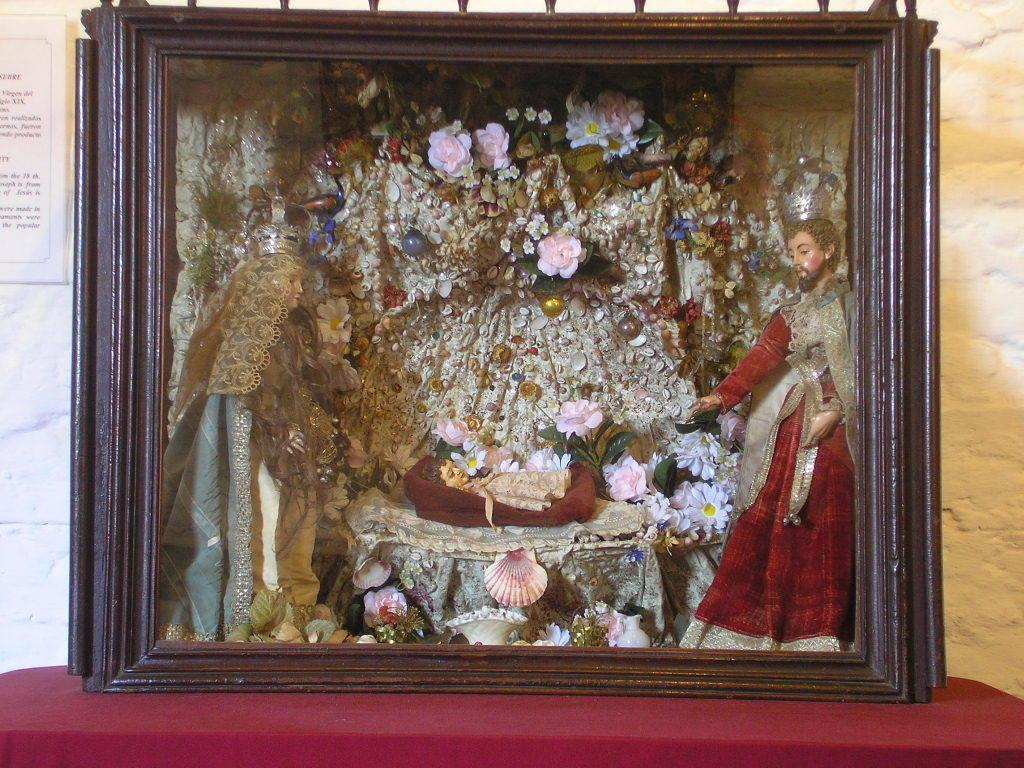What is the main object on the platform in the image? There is a photo frame on a platform in the image. What is depicted inside the photo frame? The photo frame contains a statue of people and flowers. Are there any other objects in the photo frame besides the statue and flowers? Yes, there are other objects in the photo frame. What can be seen in the background of the image? There is a wall in the background of the image, and a poster is on the wall. Can you tell me how many roots are visible in the image? There are no roots present in the image. Is there a volcano erupting in the background of the image? There is no volcano present in the image. 